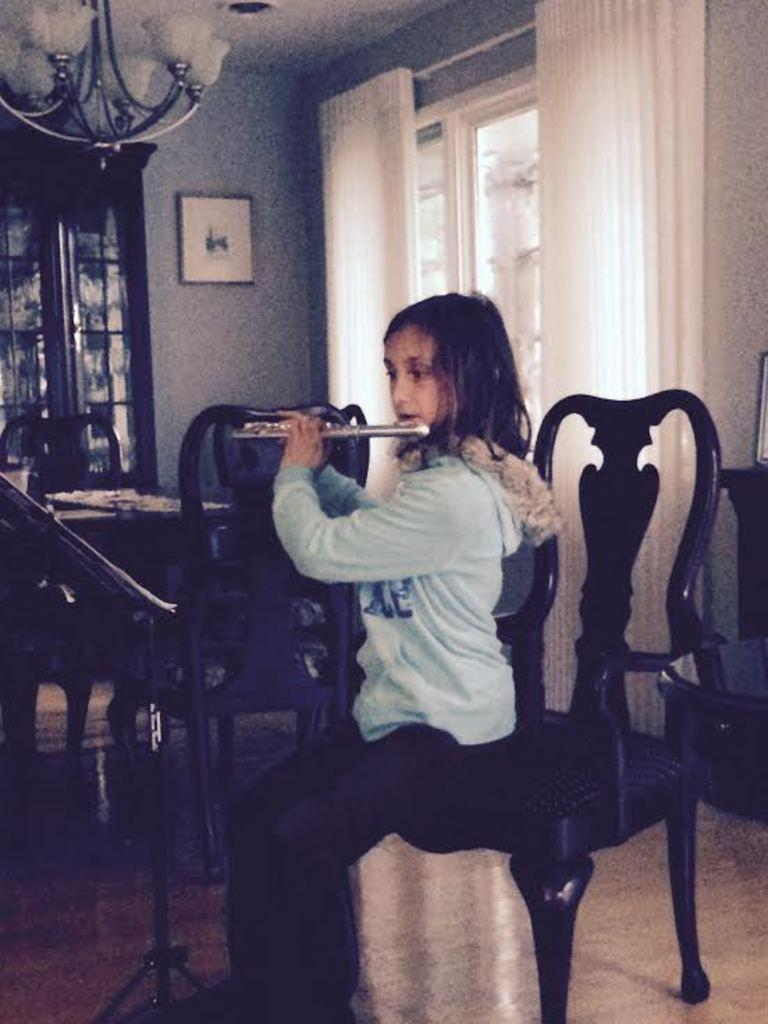What is the girl in the image doing? The girl is sitting on a chair in the image. What is the girl holding? The girl is holding a musical instrument. What can be seen in the background of the image? There is a wall, a window with a curtain, a photo frame, and a table with chairs in the background of the image. What type of lunch is the girl eating in the image? There is no lunch present in the image; the girl is holding a musical instrument. What shape is the dinner table in the image? There is no dinner table present in the image. 